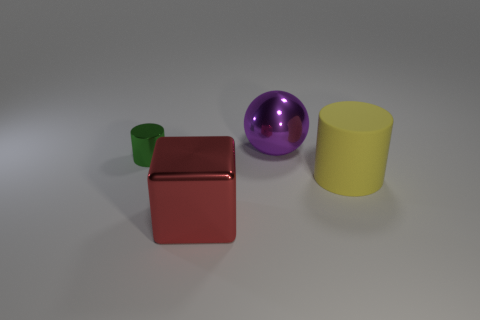There is a shiny object that is the same size as the red metallic cube; what color is it?
Give a very brief answer. Purple. Are there the same number of purple metal objects that are behind the sphere and green objects right of the big yellow matte cylinder?
Provide a short and direct response. Yes. What is the material of the cylinder that is right of the big metallic object that is on the right side of the cube?
Your answer should be compact. Rubber. What number of things are either rubber objects or green cylinders?
Provide a short and direct response. 2. Is the number of shiny spheres less than the number of big objects?
Provide a short and direct response. Yes. The ball that is made of the same material as the large red cube is what size?
Offer a very short reply. Large. How big is the metal ball?
Offer a terse response. Large. What shape is the big red shiny object?
Provide a short and direct response. Cube. There is a large shiny thing that is behind the tiny metal thing; does it have the same color as the tiny object?
Your response must be concise. No. What size is the yellow object that is the same shape as the green metallic object?
Provide a short and direct response. Large. 